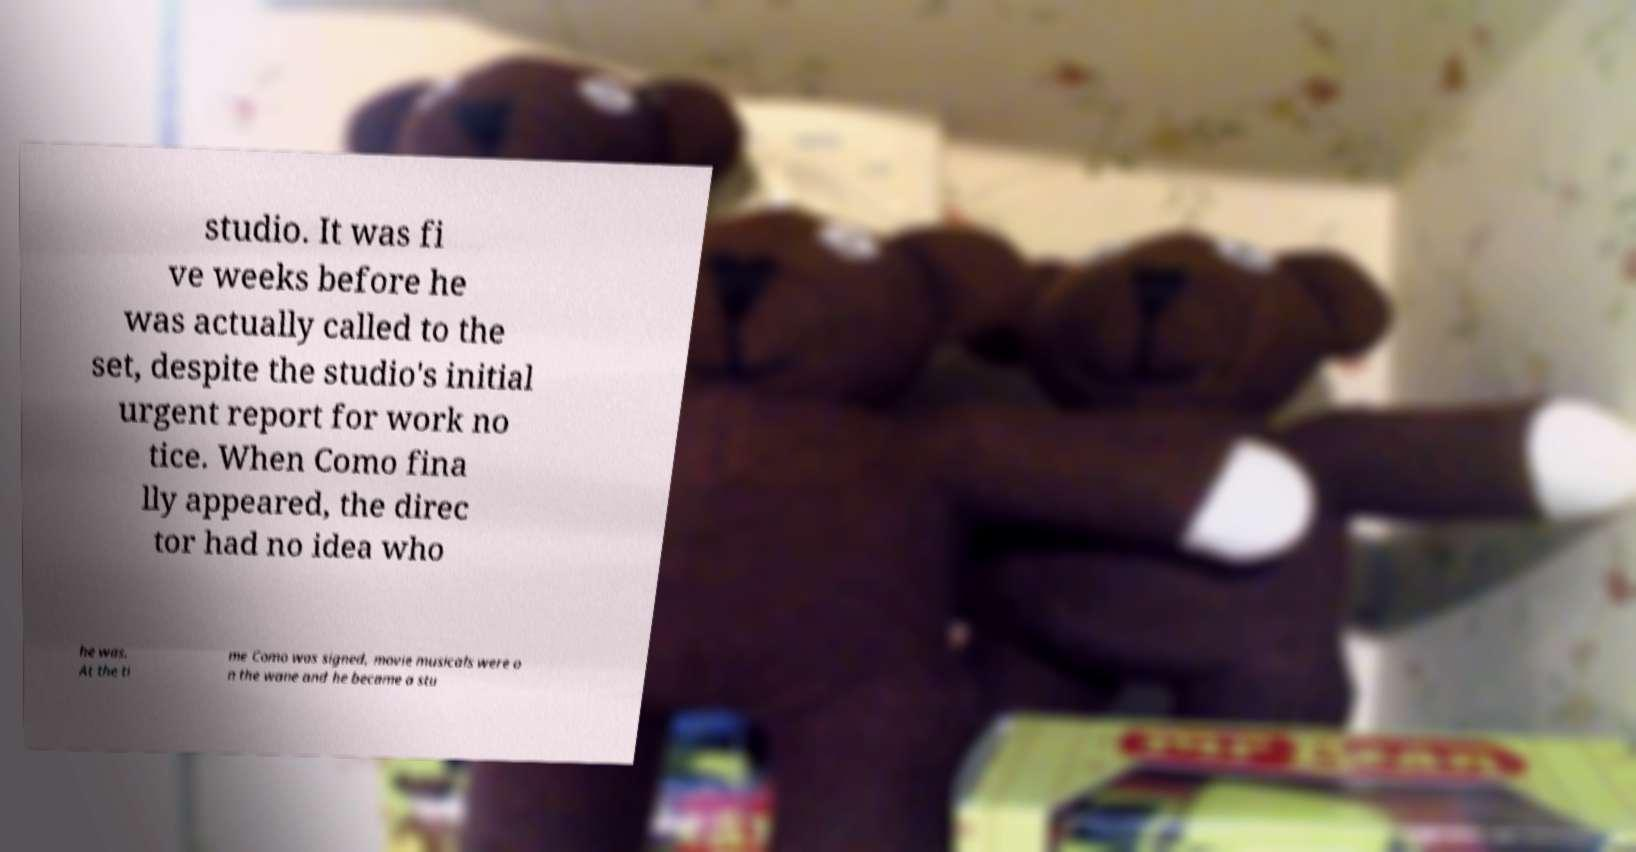For documentation purposes, I need the text within this image transcribed. Could you provide that? studio. It was fi ve weeks before he was actually called to the set, despite the studio's initial urgent report for work no tice. When Como fina lly appeared, the direc tor had no idea who he was. At the ti me Como was signed, movie musicals were o n the wane and he became a stu 